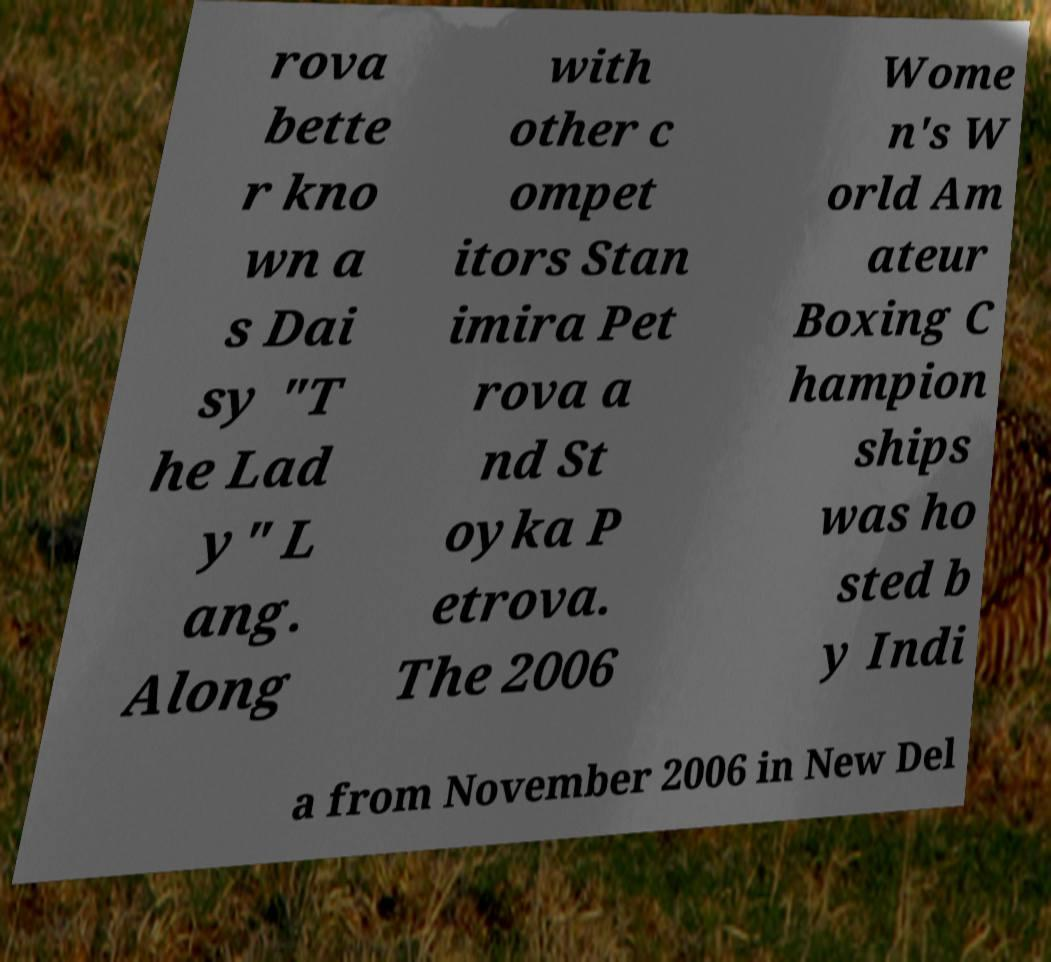Can you read and provide the text displayed in the image?This photo seems to have some interesting text. Can you extract and type it out for me? rova bette r kno wn a s Dai sy "T he Lad y" L ang. Along with other c ompet itors Stan imira Pet rova a nd St oyka P etrova. The 2006 Wome n's W orld Am ateur Boxing C hampion ships was ho sted b y Indi a from November 2006 in New Del 